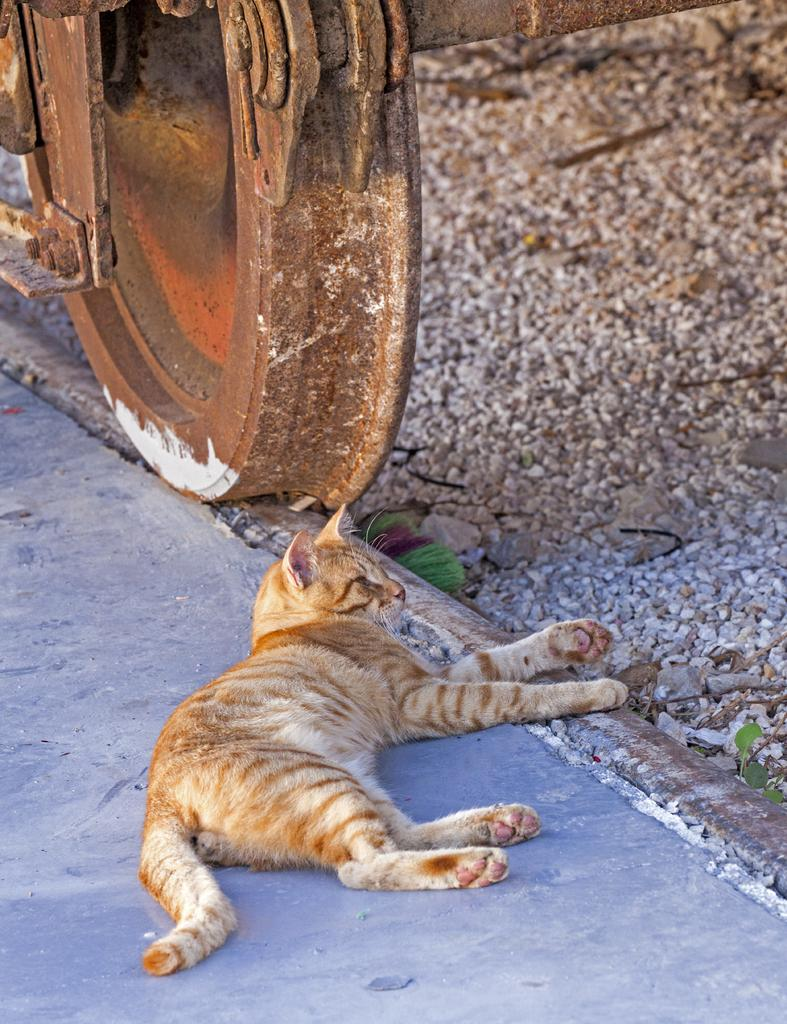What type of animal is in the image? There is a cat in the image. What is the cat doing in the image? The cat is lying down. What can be seen on the right side of the image? There are stones on the right side of the image. What is the wheel of in the image? There is a wheel of a train in the image. What type of beds can be seen in the image? There are no beds present in the image. What is the cat using to tie up the cork in the image? There is no cork or any tying activity involving the cat in the image. 